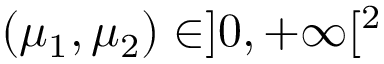Convert formula to latex. <formula><loc_0><loc_0><loc_500><loc_500>( \mu _ { 1 } , \mu _ { 2 } ) \in ] 0 , + \infty [ ^ { 2 }</formula> 